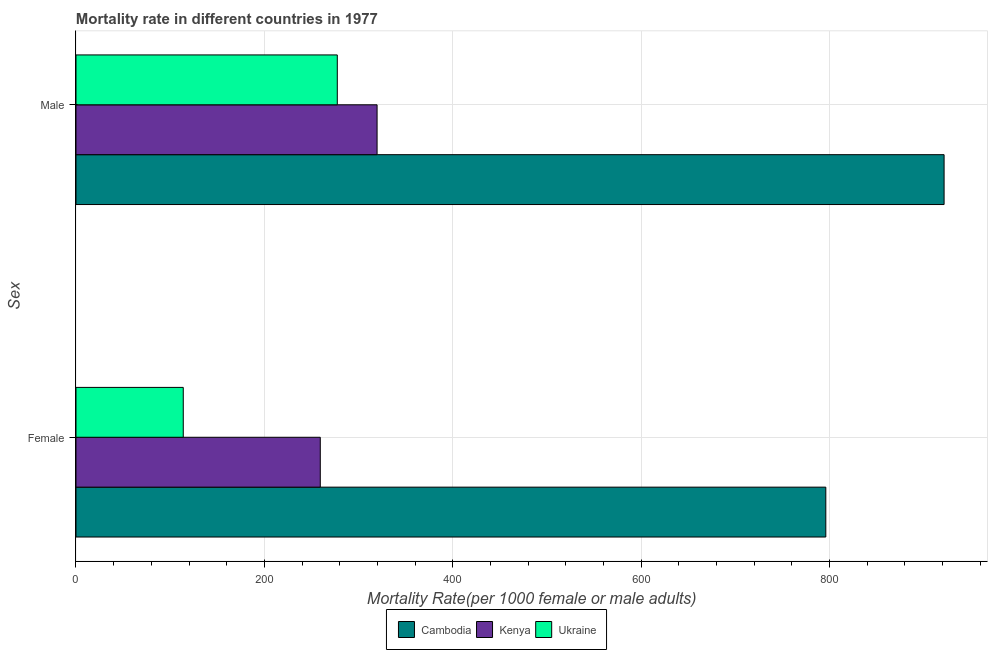How many bars are there on the 1st tick from the top?
Give a very brief answer. 3. What is the label of the 1st group of bars from the top?
Keep it short and to the point. Male. What is the male mortality rate in Ukraine?
Make the answer very short. 277.42. Across all countries, what is the maximum male mortality rate?
Provide a succinct answer. 921.63. Across all countries, what is the minimum male mortality rate?
Provide a short and direct response. 277.42. In which country was the female mortality rate maximum?
Keep it short and to the point. Cambodia. In which country was the male mortality rate minimum?
Your response must be concise. Ukraine. What is the total female mortality rate in the graph?
Keep it short and to the point. 1169.31. What is the difference between the female mortality rate in Kenya and that in Ukraine?
Your answer should be compact. 145.46. What is the difference between the male mortality rate in Cambodia and the female mortality rate in Kenya?
Ensure brevity in your answer.  662.27. What is the average male mortality rate per country?
Ensure brevity in your answer.  506.23. What is the difference between the female mortality rate and male mortality rate in Ukraine?
Provide a short and direct response. -163.52. In how many countries, is the male mortality rate greater than 560 ?
Make the answer very short. 1. What is the ratio of the female mortality rate in Kenya to that in Cambodia?
Your response must be concise. 0.33. Is the male mortality rate in Ukraine less than that in Kenya?
Provide a short and direct response. Yes. In how many countries, is the male mortality rate greater than the average male mortality rate taken over all countries?
Make the answer very short. 1. What does the 1st bar from the top in Female represents?
Your response must be concise. Ukraine. What does the 1st bar from the bottom in Female represents?
Offer a very short reply. Cambodia. How many bars are there?
Give a very brief answer. 6. Are all the bars in the graph horizontal?
Your response must be concise. Yes. How many countries are there in the graph?
Keep it short and to the point. 3. Does the graph contain grids?
Give a very brief answer. Yes. Where does the legend appear in the graph?
Ensure brevity in your answer.  Bottom center. How many legend labels are there?
Keep it short and to the point. 3. How are the legend labels stacked?
Your answer should be very brief. Horizontal. What is the title of the graph?
Your answer should be compact. Mortality rate in different countries in 1977. Does "Uruguay" appear as one of the legend labels in the graph?
Offer a terse response. No. What is the label or title of the X-axis?
Your response must be concise. Mortality Rate(per 1000 female or male adults). What is the label or title of the Y-axis?
Offer a terse response. Sex. What is the Mortality Rate(per 1000 female or male adults) of Cambodia in Female?
Provide a short and direct response. 796.06. What is the Mortality Rate(per 1000 female or male adults) of Kenya in Female?
Provide a succinct answer. 259.36. What is the Mortality Rate(per 1000 female or male adults) in Ukraine in Female?
Your response must be concise. 113.9. What is the Mortality Rate(per 1000 female or male adults) in Cambodia in Male?
Ensure brevity in your answer.  921.63. What is the Mortality Rate(per 1000 female or male adults) in Kenya in Male?
Provide a succinct answer. 319.66. What is the Mortality Rate(per 1000 female or male adults) of Ukraine in Male?
Provide a short and direct response. 277.42. Across all Sex, what is the maximum Mortality Rate(per 1000 female or male adults) of Cambodia?
Keep it short and to the point. 921.63. Across all Sex, what is the maximum Mortality Rate(per 1000 female or male adults) in Kenya?
Provide a short and direct response. 319.66. Across all Sex, what is the maximum Mortality Rate(per 1000 female or male adults) of Ukraine?
Offer a terse response. 277.42. Across all Sex, what is the minimum Mortality Rate(per 1000 female or male adults) in Cambodia?
Give a very brief answer. 796.06. Across all Sex, what is the minimum Mortality Rate(per 1000 female or male adults) of Kenya?
Provide a short and direct response. 259.36. Across all Sex, what is the minimum Mortality Rate(per 1000 female or male adults) of Ukraine?
Provide a succinct answer. 113.9. What is the total Mortality Rate(per 1000 female or male adults) in Cambodia in the graph?
Your answer should be very brief. 1717.69. What is the total Mortality Rate(per 1000 female or male adults) of Kenya in the graph?
Give a very brief answer. 579.02. What is the total Mortality Rate(per 1000 female or male adults) in Ukraine in the graph?
Provide a short and direct response. 391.31. What is the difference between the Mortality Rate(per 1000 female or male adults) in Cambodia in Female and that in Male?
Your answer should be very brief. -125.57. What is the difference between the Mortality Rate(per 1000 female or male adults) in Kenya in Female and that in Male?
Keep it short and to the point. -60.3. What is the difference between the Mortality Rate(per 1000 female or male adults) in Ukraine in Female and that in Male?
Your answer should be compact. -163.52. What is the difference between the Mortality Rate(per 1000 female or male adults) of Cambodia in Female and the Mortality Rate(per 1000 female or male adults) of Kenya in Male?
Offer a very short reply. 476.4. What is the difference between the Mortality Rate(per 1000 female or male adults) of Cambodia in Female and the Mortality Rate(per 1000 female or male adults) of Ukraine in Male?
Provide a succinct answer. 518.64. What is the difference between the Mortality Rate(per 1000 female or male adults) of Kenya in Female and the Mortality Rate(per 1000 female or male adults) of Ukraine in Male?
Offer a very short reply. -18.06. What is the average Mortality Rate(per 1000 female or male adults) in Cambodia per Sex?
Your answer should be very brief. 858.84. What is the average Mortality Rate(per 1000 female or male adults) in Kenya per Sex?
Provide a succinct answer. 289.51. What is the average Mortality Rate(per 1000 female or male adults) of Ukraine per Sex?
Offer a very short reply. 195.66. What is the difference between the Mortality Rate(per 1000 female or male adults) in Cambodia and Mortality Rate(per 1000 female or male adults) in Kenya in Female?
Keep it short and to the point. 536.7. What is the difference between the Mortality Rate(per 1000 female or male adults) in Cambodia and Mortality Rate(per 1000 female or male adults) in Ukraine in Female?
Provide a short and direct response. 682.16. What is the difference between the Mortality Rate(per 1000 female or male adults) in Kenya and Mortality Rate(per 1000 female or male adults) in Ukraine in Female?
Keep it short and to the point. 145.46. What is the difference between the Mortality Rate(per 1000 female or male adults) in Cambodia and Mortality Rate(per 1000 female or male adults) in Kenya in Male?
Provide a short and direct response. 601.97. What is the difference between the Mortality Rate(per 1000 female or male adults) in Cambodia and Mortality Rate(per 1000 female or male adults) in Ukraine in Male?
Give a very brief answer. 644.22. What is the difference between the Mortality Rate(per 1000 female or male adults) in Kenya and Mortality Rate(per 1000 female or male adults) in Ukraine in Male?
Offer a terse response. 42.24. What is the ratio of the Mortality Rate(per 1000 female or male adults) of Cambodia in Female to that in Male?
Provide a succinct answer. 0.86. What is the ratio of the Mortality Rate(per 1000 female or male adults) of Kenya in Female to that in Male?
Give a very brief answer. 0.81. What is the ratio of the Mortality Rate(per 1000 female or male adults) of Ukraine in Female to that in Male?
Give a very brief answer. 0.41. What is the difference between the highest and the second highest Mortality Rate(per 1000 female or male adults) in Cambodia?
Your response must be concise. 125.57. What is the difference between the highest and the second highest Mortality Rate(per 1000 female or male adults) in Kenya?
Give a very brief answer. 60.3. What is the difference between the highest and the second highest Mortality Rate(per 1000 female or male adults) in Ukraine?
Your response must be concise. 163.52. What is the difference between the highest and the lowest Mortality Rate(per 1000 female or male adults) of Cambodia?
Provide a short and direct response. 125.57. What is the difference between the highest and the lowest Mortality Rate(per 1000 female or male adults) of Kenya?
Offer a very short reply. 60.3. What is the difference between the highest and the lowest Mortality Rate(per 1000 female or male adults) of Ukraine?
Ensure brevity in your answer.  163.52. 